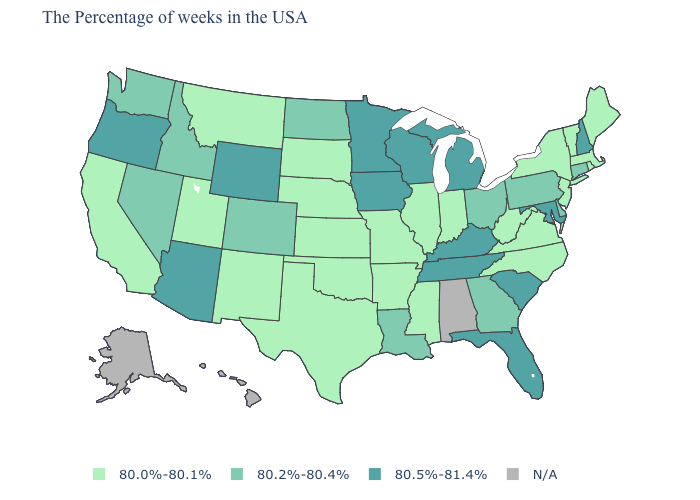Is the legend a continuous bar?
Answer briefly. No. Name the states that have a value in the range 80.0%-80.1%?
Quick response, please. Maine, Massachusetts, Rhode Island, Vermont, New York, New Jersey, Virginia, North Carolina, West Virginia, Indiana, Illinois, Mississippi, Missouri, Arkansas, Kansas, Nebraska, Oklahoma, Texas, South Dakota, New Mexico, Utah, Montana, California. What is the value of Mississippi?
Concise answer only. 80.0%-80.1%. Is the legend a continuous bar?
Give a very brief answer. No. Which states have the lowest value in the South?
Give a very brief answer. Virginia, North Carolina, West Virginia, Mississippi, Arkansas, Oklahoma, Texas. Name the states that have a value in the range N/A?
Keep it brief. Alabama, Alaska, Hawaii. What is the highest value in states that border Washington?
Short answer required. 80.5%-81.4%. What is the highest value in states that border Utah?
Be succinct. 80.5%-81.4%. What is the value of Oregon?
Give a very brief answer. 80.5%-81.4%. Name the states that have a value in the range N/A?
Answer briefly. Alabama, Alaska, Hawaii. Does Nebraska have the highest value in the MidWest?
Concise answer only. No. How many symbols are there in the legend?
Quick response, please. 4. Name the states that have a value in the range 80.2%-80.4%?
Give a very brief answer. Connecticut, Delaware, Pennsylvania, Ohio, Georgia, Louisiana, North Dakota, Colorado, Idaho, Nevada, Washington. Does Maryland have the highest value in the USA?
Answer briefly. Yes. Does the map have missing data?
Quick response, please. Yes. 